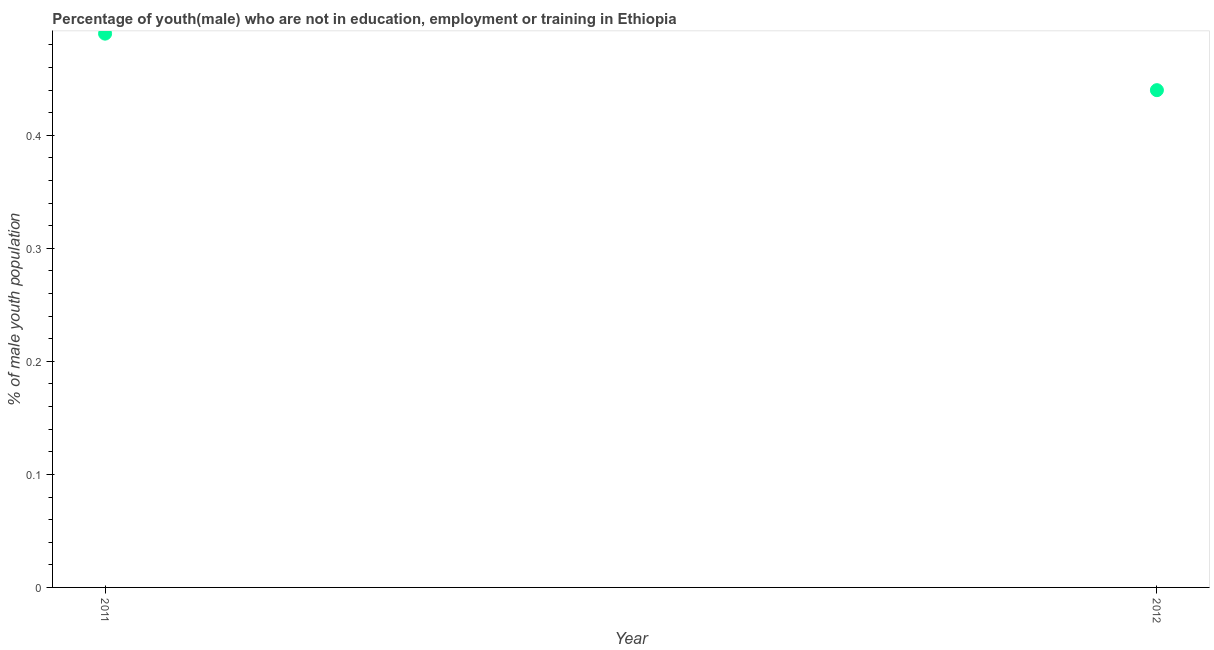What is the unemployed male youth population in 2011?
Offer a very short reply. 0.49. Across all years, what is the maximum unemployed male youth population?
Your answer should be compact. 0.49. Across all years, what is the minimum unemployed male youth population?
Keep it short and to the point. 0.44. In which year was the unemployed male youth population maximum?
Offer a terse response. 2011. In which year was the unemployed male youth population minimum?
Your answer should be very brief. 2012. What is the sum of the unemployed male youth population?
Keep it short and to the point. 0.93. What is the difference between the unemployed male youth population in 2011 and 2012?
Offer a terse response. 0.05. What is the average unemployed male youth population per year?
Your response must be concise. 0.47. What is the median unemployed male youth population?
Ensure brevity in your answer.  0.47. In how many years, is the unemployed male youth population greater than 0.06 %?
Offer a very short reply. 2. What is the ratio of the unemployed male youth population in 2011 to that in 2012?
Your response must be concise. 1.11. In how many years, is the unemployed male youth population greater than the average unemployed male youth population taken over all years?
Offer a very short reply. 1. Does the unemployed male youth population monotonically increase over the years?
Offer a very short reply. No. How many years are there in the graph?
Your answer should be very brief. 2. What is the difference between two consecutive major ticks on the Y-axis?
Give a very brief answer. 0.1. Does the graph contain any zero values?
Offer a terse response. No. What is the title of the graph?
Ensure brevity in your answer.  Percentage of youth(male) who are not in education, employment or training in Ethiopia. What is the label or title of the Y-axis?
Offer a terse response. % of male youth population. What is the % of male youth population in 2011?
Your answer should be very brief. 0.49. What is the % of male youth population in 2012?
Provide a short and direct response. 0.44. What is the difference between the % of male youth population in 2011 and 2012?
Keep it short and to the point. 0.05. What is the ratio of the % of male youth population in 2011 to that in 2012?
Your answer should be compact. 1.11. 